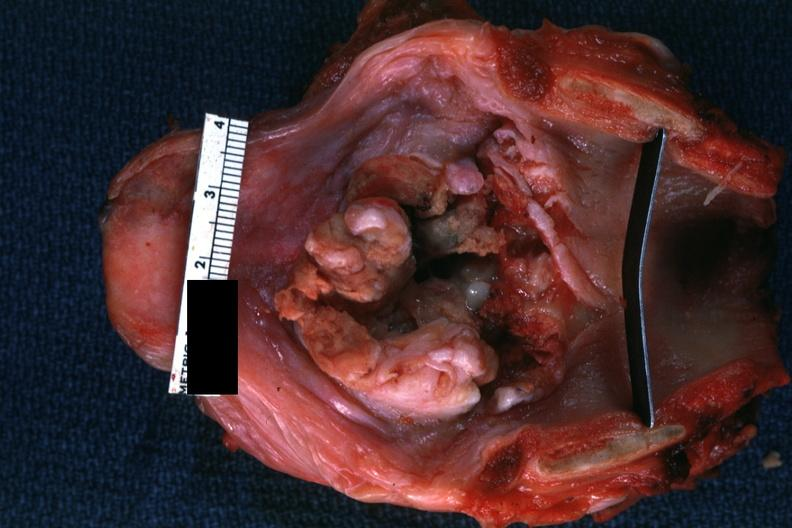does this image show large lesion good but not the best?
Answer the question using a single word or phrase. Yes 